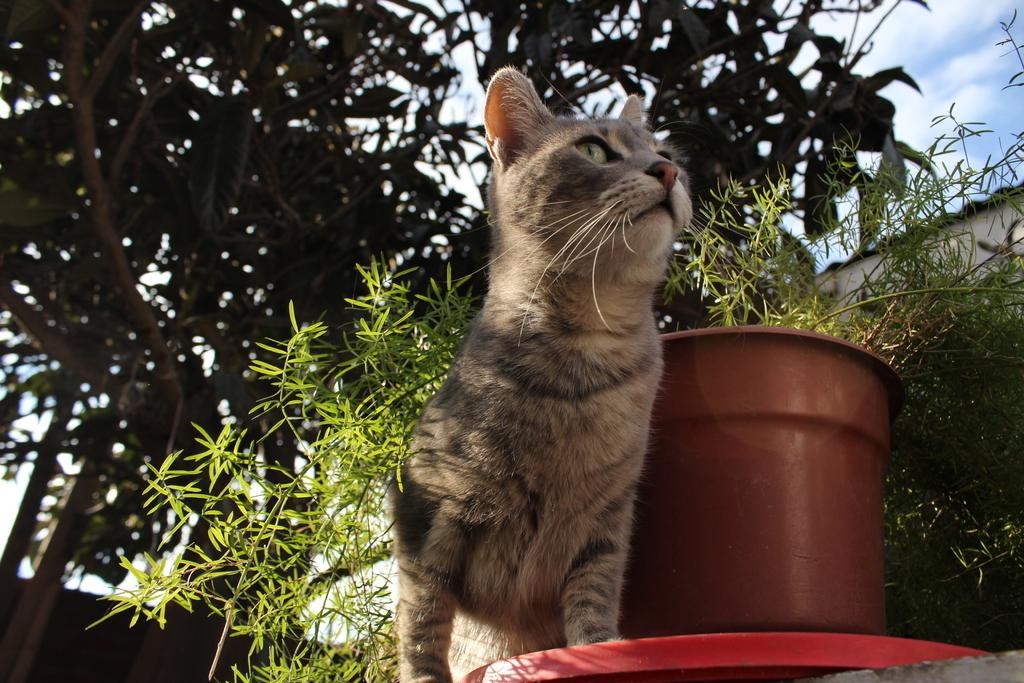What type of animal can be seen in the image? There is a cat in the image. Where is the cat located in relation to other objects in the image? The cat is sitting near a house plant. What other types of plants are visible in the image? There are plants in the image. What can be seen in the background of the image? Leaves and the sky are visible in the background of the image. What is the condition of the sky in the image? Clouds are present in the sky. What type of flesh can be seen on the cat's face in the image? There is no flesh visible on the cat's face in the image; it is a cat, and cats have fur, not exposed flesh. Can you describe the man in the image? There is no man present in the image; it features a cat sitting near a house plant. 